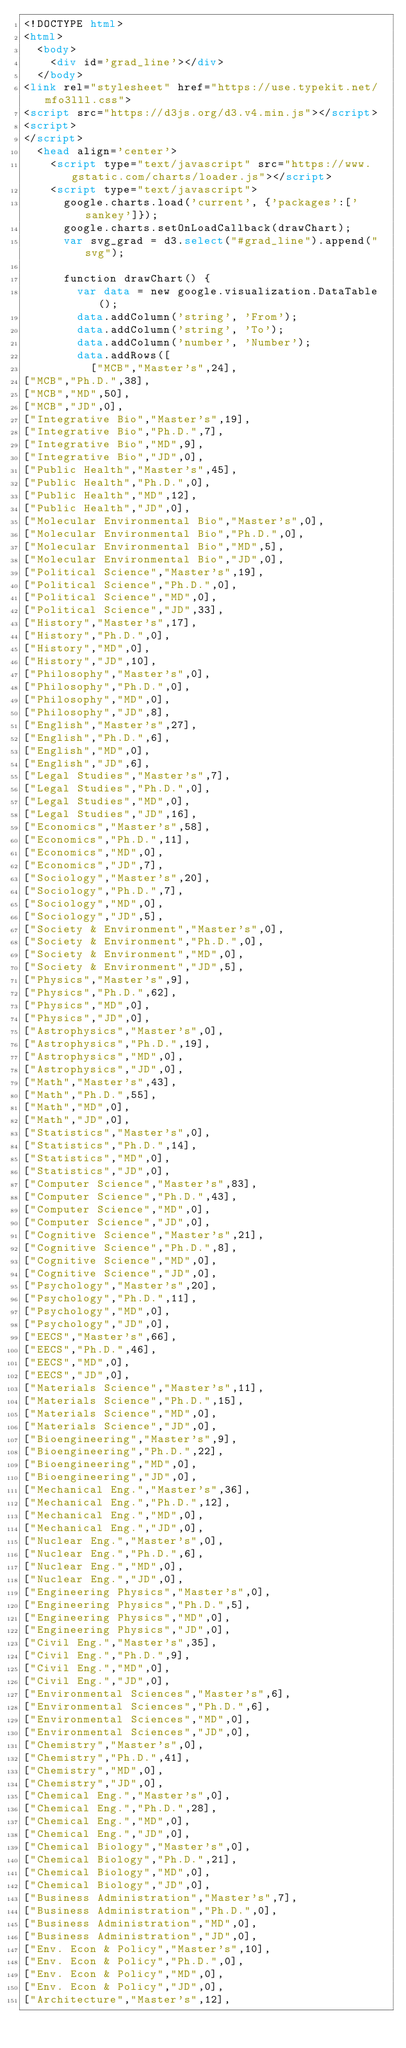Convert code to text. <code><loc_0><loc_0><loc_500><loc_500><_HTML_><!DOCTYPE html>
<html>
  <body>
    <div id='grad_line'></div>
  </body>
<link rel="stylesheet" href="https://use.typekit.net/mfo3lll.css">
<script src="https://d3js.org/d3.v4.min.js"></script>
<script>
</script>
  <head align='center'>
    <script type="text/javascript" src="https://www.gstatic.com/charts/loader.js"></script>
    <script type="text/javascript">
      google.charts.load('current', {'packages':['sankey']});
      google.charts.setOnLoadCallback(drawChart);
      var svg_grad = d3.select("#grad_line").append("svg");

      function drawChart() {
        var data = new google.visualization.DataTable();
        data.addColumn('string', 'From');
        data.addColumn('string', 'To');
        data.addColumn('number', 'Number');
        data.addRows([
          ["MCB","Master's",24],
["MCB","Ph.D.",38],
["MCB","MD",50],
["MCB","JD",0],
["Integrative Bio","Master's",19],
["Integrative Bio","Ph.D.",7],
["Integrative Bio","MD",9],
["Integrative Bio","JD",0],
["Public Health","Master's",45],
["Public Health","Ph.D.",0],
["Public Health","MD",12],
["Public Health","JD",0],
["Molecular Environmental Bio","Master's",0],
["Molecular Environmental Bio","Ph.D.",0],
["Molecular Environmental Bio","MD",5],
["Molecular Environmental Bio","JD",0],
["Political Science","Master's",19],
["Political Science","Ph.D.",0],
["Political Science","MD",0],
["Political Science","JD",33],
["History","Master's",17],
["History","Ph.D.",0],
["History","MD",0],
["History","JD",10],
["Philosophy","Master's",0],
["Philosophy","Ph.D.",0],
["Philosophy","MD",0],
["Philosophy","JD",8],
["English","Master's",27],
["English","Ph.D.",6],
["English","MD",0],
["English","JD",6],
["Legal Studies","Master's",7],
["Legal Studies","Ph.D.",0],
["Legal Studies","MD",0],
["Legal Studies","JD",16],
["Economics","Master's",58],
["Economics","Ph.D.",11],
["Economics","MD",0],
["Economics","JD",7],
["Sociology","Master's",20],
["Sociology","Ph.D.",7],
["Sociology","MD",0],
["Sociology","JD",5],
["Society & Environment","Master's",0],
["Society & Environment","Ph.D.",0],
["Society & Environment","MD",0],
["Society & Environment","JD",5],
["Physics","Master's",9],
["Physics","Ph.D.",62],
["Physics","MD",0],
["Physics","JD",0],
["Astrophysics","Master's",0],
["Astrophysics","Ph.D.",19],
["Astrophysics","MD",0],
["Astrophysics","JD",0],
["Math","Master's",43],
["Math","Ph.D.",55],
["Math","MD",0],
["Math","JD",0],
["Statistics","Master's",0],
["Statistics","Ph.D.",14],
["Statistics","MD",0],
["Statistics","JD",0],
["Computer Science","Master's",83],
["Computer Science","Ph.D.",43],
["Computer Science","MD",0],
["Computer Science","JD",0],
["Cognitive Science","Master's",21],
["Cognitive Science","Ph.D.",8],
["Cognitive Science","MD",0],
["Cognitive Science","JD",0],
["Psychology","Master's",20],
["Psychology","Ph.D.",11],
["Psychology","MD",0],
["Psychology","JD",0],
["EECS","Master's",66],
["EECS","Ph.D.",46],
["EECS","MD",0],
["EECS","JD",0],
["Materials Science","Master's",11],
["Materials Science","Ph.D.",15],
["Materials Science","MD",0],
["Materials Science","JD",0],
["Bioengineering","Master's",9],
["Bioengineering","Ph.D.",22],
["Bioengineering","MD",0],
["Bioengineering","JD",0],
["Mechanical Eng.","Master's",36],
["Mechanical Eng.","Ph.D.",12],
["Mechanical Eng.","MD",0],
["Mechanical Eng.","JD",0],
["Nuclear Eng.","Master's",0],
["Nuclear Eng.","Ph.D.",6],
["Nuclear Eng.","MD",0],
["Nuclear Eng.","JD",0],
["Engineering Physics","Master's",0],
["Engineering Physics","Ph.D.",5],
["Engineering Physics","MD",0],
["Engineering Physics","JD",0],
["Civil Eng.","Master's",35],
["Civil Eng.","Ph.D.",9],
["Civil Eng.","MD",0],
["Civil Eng.","JD",0],
["Environmental Sciences","Master's",6],
["Environmental Sciences","Ph.D.",6],
["Environmental Sciences","MD",0],
["Environmental Sciences","JD",0],
["Chemistry","Master's",0],
["Chemistry","Ph.D.",41],
["Chemistry","MD",0],
["Chemistry","JD",0],
["Chemical Eng.","Master's",0],
["Chemical Eng.","Ph.D.",28],
["Chemical Eng.","MD",0],
["Chemical Eng.","JD",0],
["Chemical Biology","Master's",0],
["Chemical Biology","Ph.D.",21],
["Chemical Biology","MD",0],
["Chemical Biology","JD",0],
["Business Administration","Master's",7],
["Business Administration","Ph.D.",0],
["Business Administration","MD",0],
["Business Administration","JD",0],
["Env. Econ & Policy","Master's",10],
["Env. Econ & Policy","Ph.D.",0],
["Env. Econ & Policy","MD",0],
["Env. Econ & Policy","JD",0],
["Architecture","Master's",12],</code> 